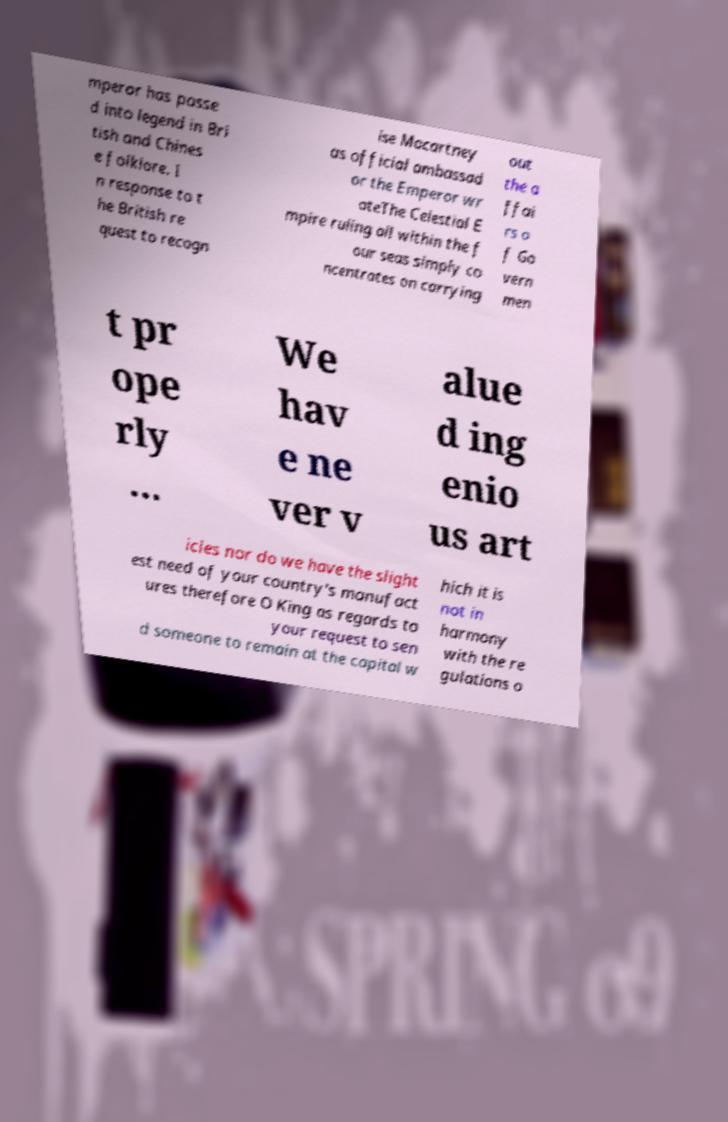Could you assist in decoding the text presented in this image and type it out clearly? mperor has passe d into legend in Bri tish and Chines e folklore. I n response to t he British re quest to recogn ise Macartney as official ambassad or the Emperor wr oteThe Celestial E mpire ruling all within the f our seas simply co ncentrates on carrying out the a ffai rs o f Go vern men t pr ope rly ... We hav e ne ver v alue d ing enio us art icles nor do we have the slight est need of your country's manufact ures therefore O King as regards to your request to sen d someone to remain at the capital w hich it is not in harmony with the re gulations o 